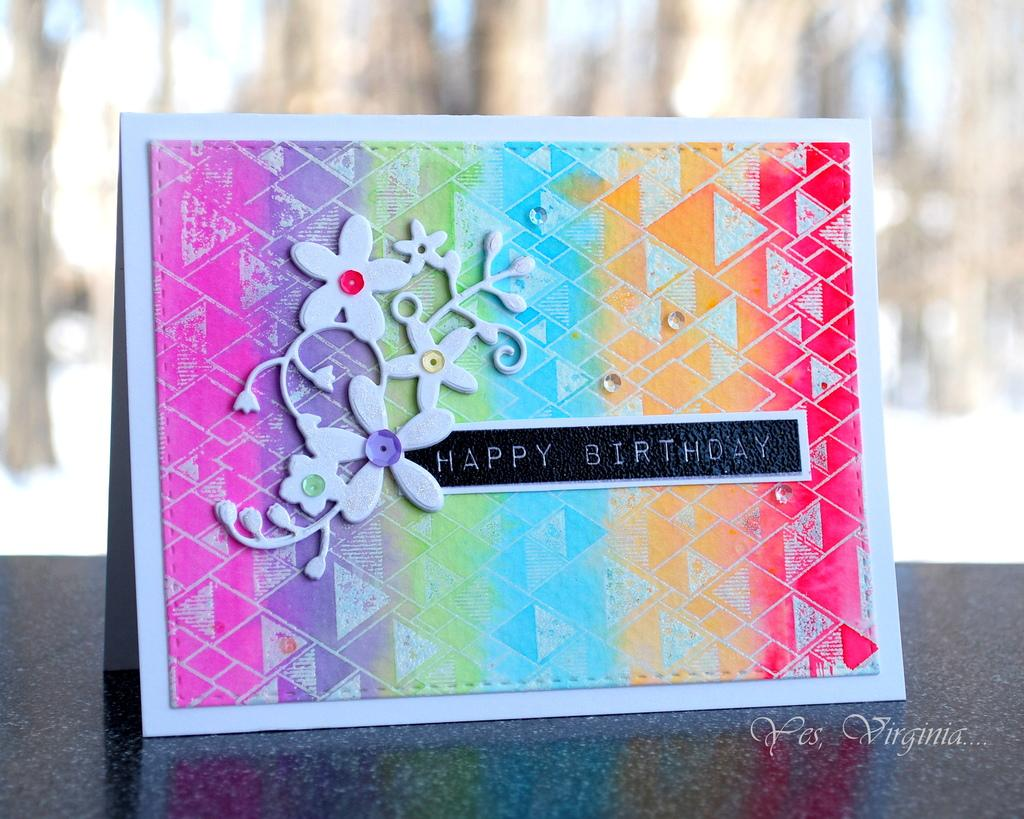What object is the main subject of the image? There is a greeting card in the image. Can you describe the appearance of the greeting card? The greeting card has multiple colors and text on it. Where is the greeting card located in the image? The greeting card is placed on a table. What can be observed about the background of the image? The background of the image is blurred. What type of crack can be seen on the yak in the image? There is no yak or crack present in the image; it features a greeting card placed on a table. How many cannons are visible in the image? There are no cannons present in the image. 